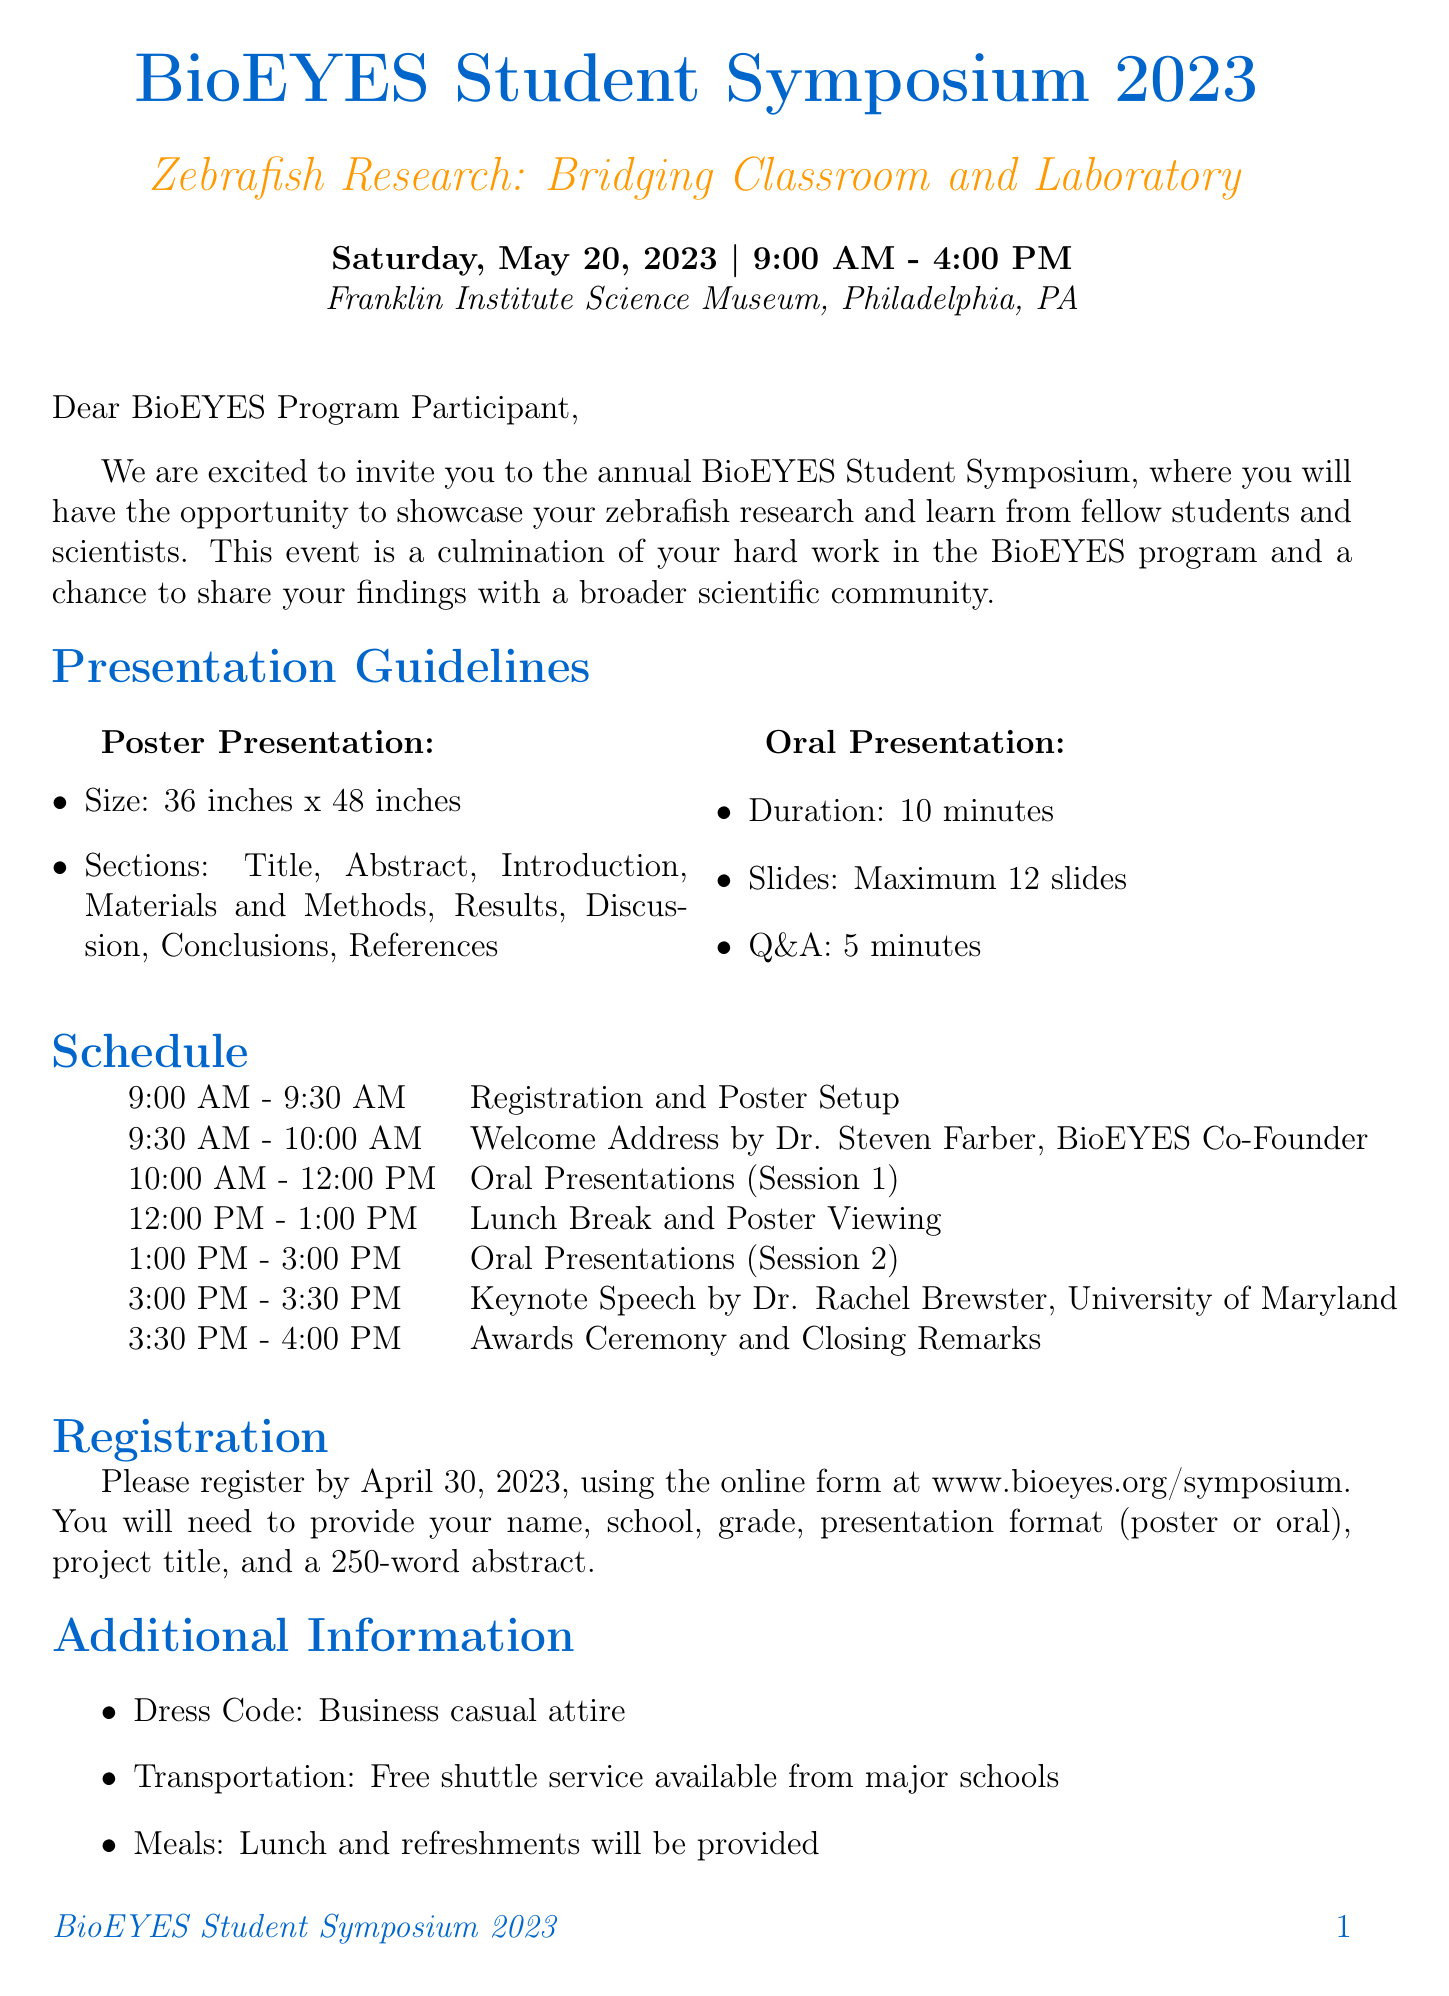What is the name of the event? The event name is explicitly stated in the document as "BioEYES Student Symposium 2023."
Answer: BioEYES Student Symposium 2023 What is the date of the symposium? The date is provided in the document as "Saturday, May 20, 2023."
Answer: Saturday, May 20, 2023 How long is each oral presentation? The duration of the oral presentations is mentioned as "10 minutes" in the guidelines.
Answer: 10 minutes What is the registration deadline? The document specifies the registration deadline as "April 30, 2023."
Answer: April 30, 2023 Who will give the keynote speech? The document names "Dr. Rachel Brewster, University of Maryland" as the keynote speaker.
Answer: Dr. Rachel Brewster, University of Maryland What is the required presentation format? The document states the presentation format can either be "Poster or Oral Presentation."
Answer: Poster or Oral Presentation What is the dress code for the event? The dress code is clearly defined in the document as "Business casual attire."
Answer: Business casual attire What will be provided for meals during the event? The document mentions that "Lunch and refreshments will be provided."
Answer: Lunch and refreshments What information is required for registration? The document lists several required pieces of information, such as name, school, and presentation format for registration.
Answer: Name, School, Grade, Presentation Format, Project Title, Abstract 